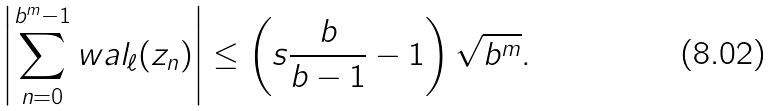<formula> <loc_0><loc_0><loc_500><loc_500>\left | \sum _ { n = 0 } ^ { b ^ { m } - 1 } w a l _ { \ell } ( z _ { n } ) \right | \leq \left ( s \frac { b } { b - 1 } - 1 \right ) \sqrt { b ^ { m } } .</formula> 